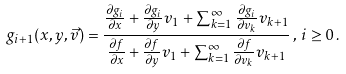Convert formula to latex. <formula><loc_0><loc_0><loc_500><loc_500>g _ { i + 1 } ( x , y , \vec { v } ) = \frac { \frac { \partial g _ { i } } { \partial x } + \frac { \partial g _ { i } } { \partial y } v _ { 1 } + \sum _ { k = 1 } ^ { \infty } \frac { \partial g _ { i } } { \partial v _ { k } } v _ { k + 1 } } { \frac { \partial f } { \partial x } + \frac { \partial f } { \partial y } v _ { 1 } + \sum _ { k = 1 } ^ { \infty } \frac { \partial f } { \partial v _ { k } } v _ { k + 1 } } \, , \, i \geq 0 \, .</formula> 